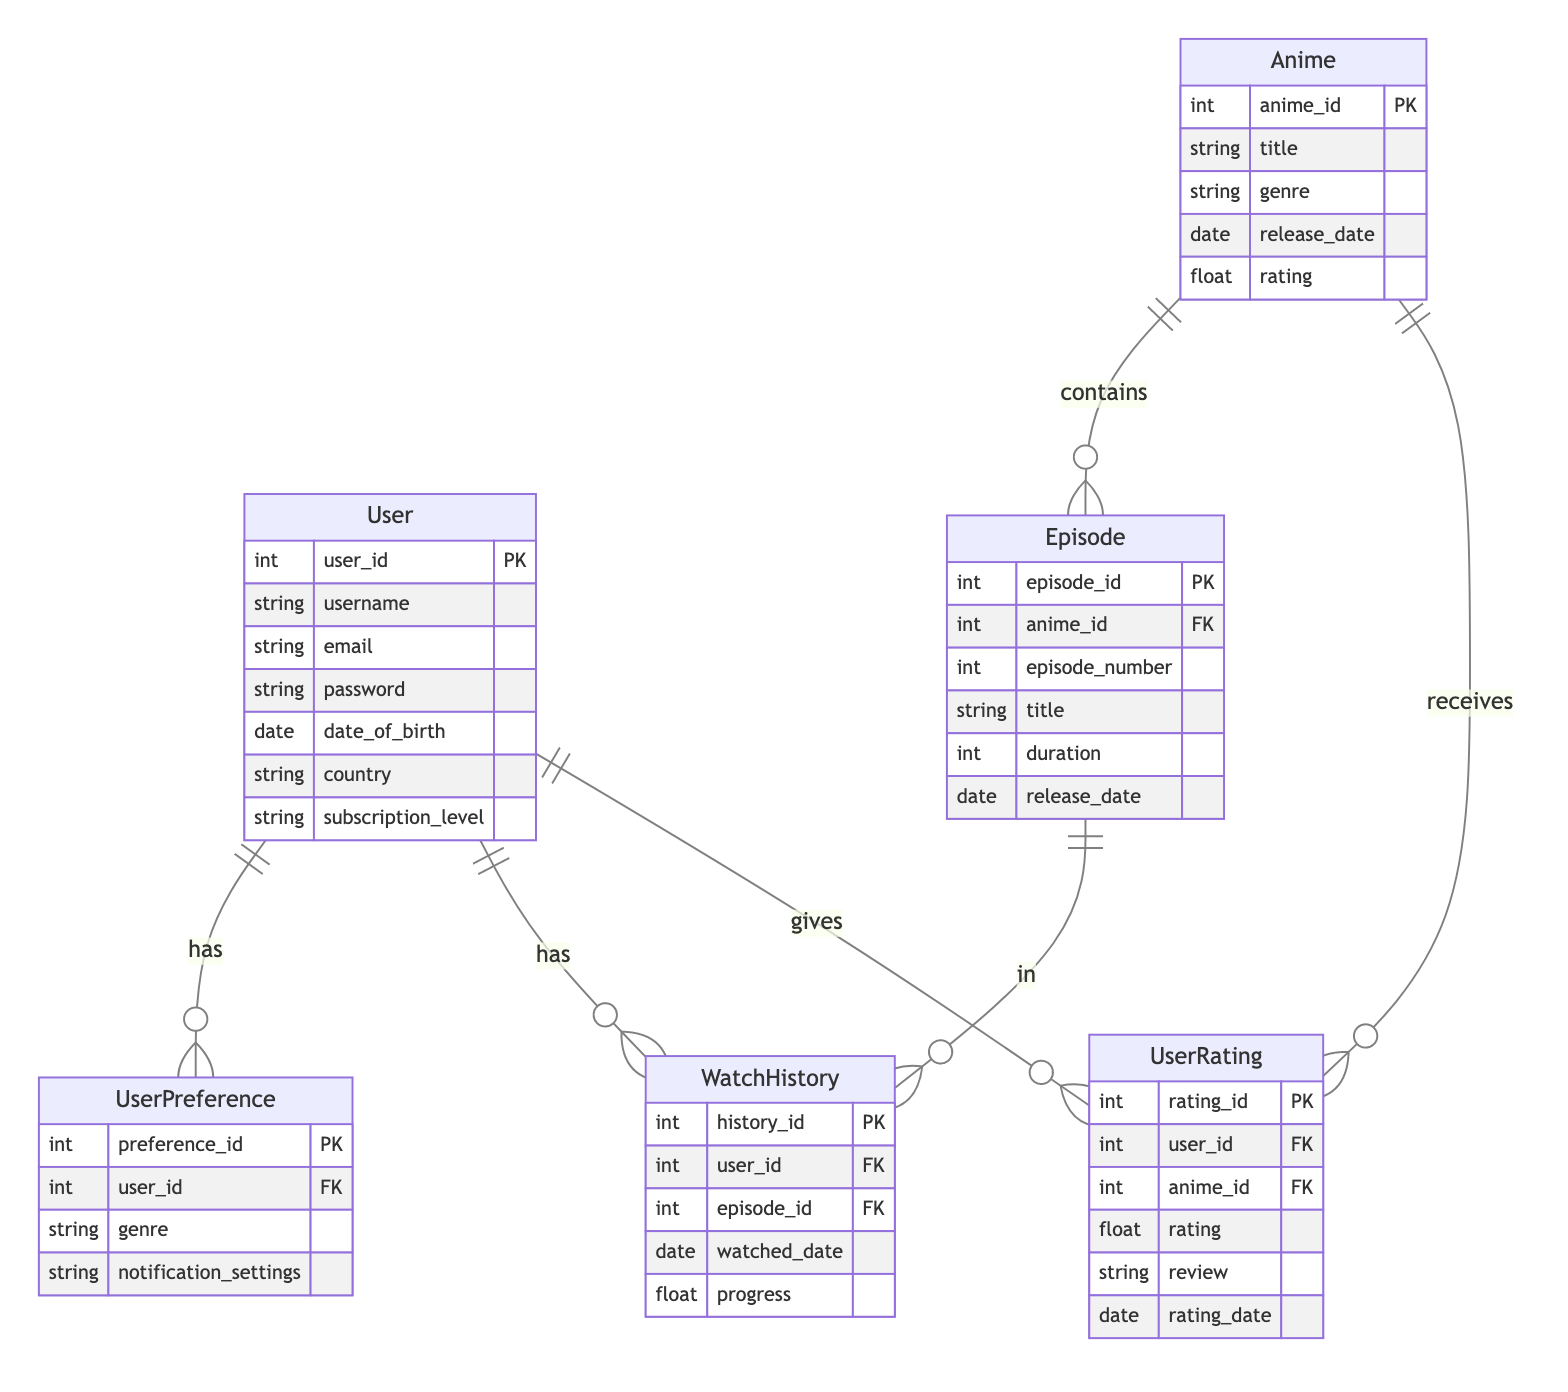What is the primary key attribute of the User entity? The primary key attribute of the User entity is user_id. This is labeled as PK in the diagram, indicating that it uniquely identifies each user.
Answer: user_id How many entities are present in the diagram? The diagram has a total of six entities: User, Anime, Episode, UserPreference, UserRating, and WatchHistory. Counting each distinct entity gives this total.
Answer: six Which relationship involves the User and Episode entities? The relationship is called User_Anime_WatchHistory, which indicates that a user can have multiple entries in their watch history for different episodes. This is highlighted by the "has" label and the one-to-many relationship notation.
Answer: User_Anime_WatchHistory What does the UserRating relationship represent? The UserRating relationship represents a many-to-many interaction between User and Anime. This indicates that users can give ratings to multiple anime, and any anime can be rated by multiple users, as shown by the connecting lines and "gives" label.
Answer: many-to-many How many attributes does the Anime entity have? The Anime entity has five attributes, which are anime_id, title, genre, release_date, and rating, as listed in the diagram under the Anime entity.
Answer: five What does the WatchHistory table track? The WatchHistory table tracks the episodes watched by users, including details like the watched date and progress. This is evident from its attributes, which capture the time and status of each episode a user has watched.
Answer: episodes watched What type of relationship is between Anime and Episode? The relationship is a one-to-many relationship, indicated by the connection line and the notation that shows one Anime can contain multiple Episodes.
Answer: one-to-many What does the UserPreference table capture? The UserPreference table captures the user's genre preferences and notification settings, as indicated by its attributes. This reflects the user's individual preferences for the types of anime they would like to be notified about.
Answer: genre preferences and notification settings Which entity has the most relationships linked to it? The User entity has the most relationships linked to it: it has relationships with UserPreference, WatchHistory, and UserRating, indicating various ways users interact with the system. This can be seen by counting the relationships stemming from the User entity.
Answer: User 